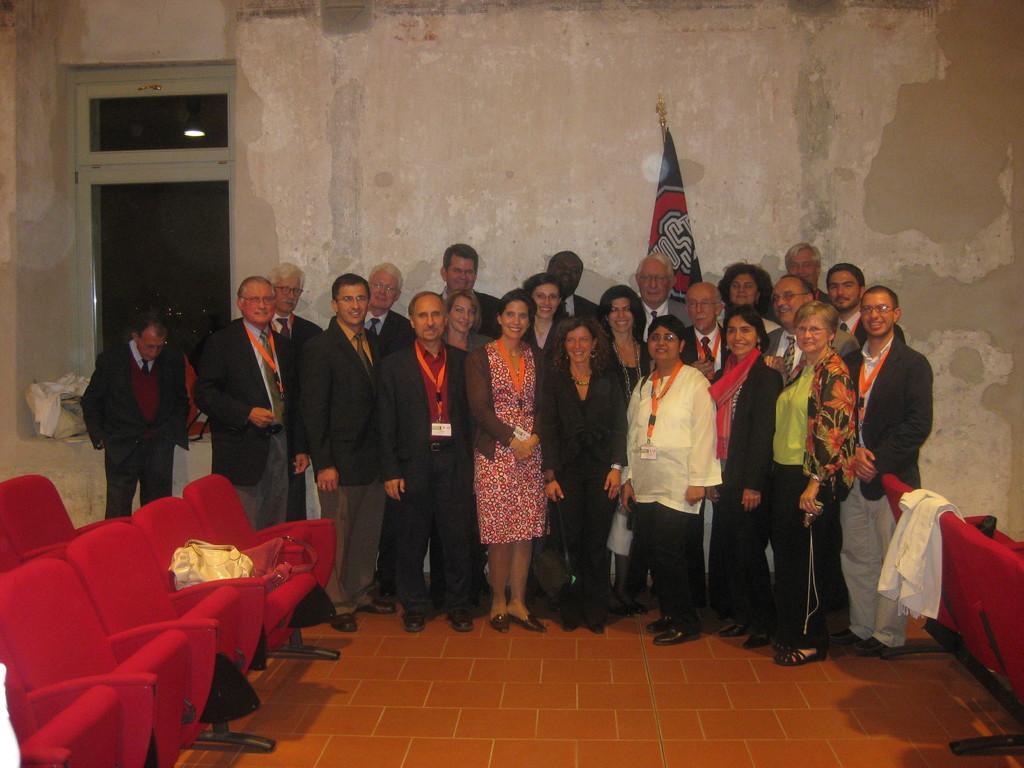In one or two sentences, can you explain what this image depicts? This picture seems to be clicked inside the hall. In the foreground we can see the red color chairs and sling bags. In the center we can see the group of persons smiling and standing on the pavement. In the background we can see the wall, window, flag and some other objects. 